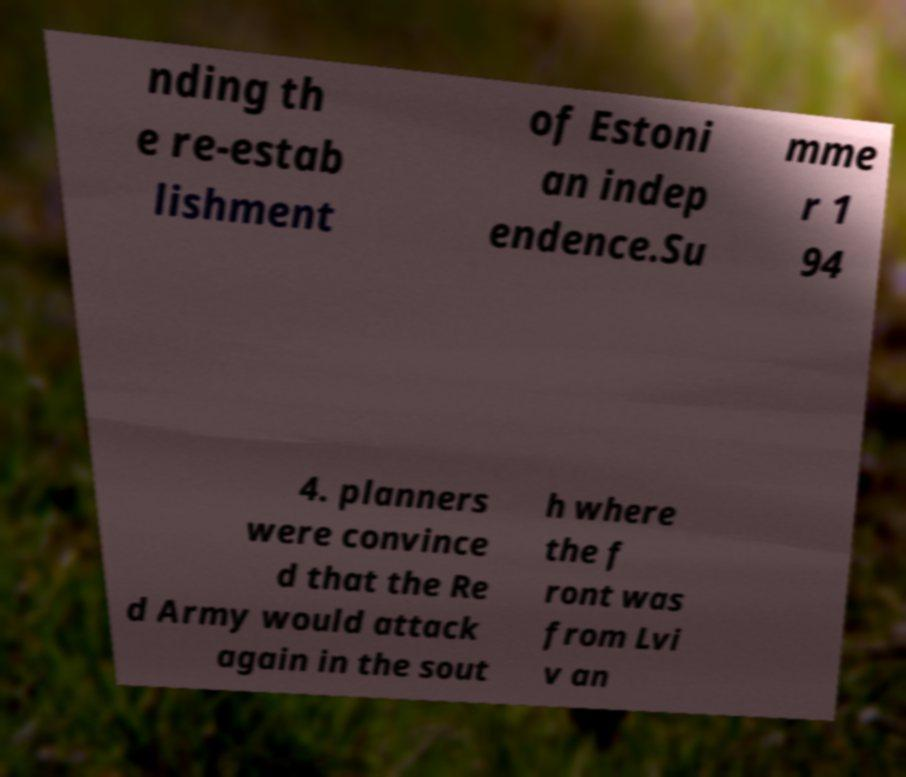Could you extract and type out the text from this image? nding th e re-estab lishment of Estoni an indep endence.Su mme r 1 94 4. planners were convince d that the Re d Army would attack again in the sout h where the f ront was from Lvi v an 